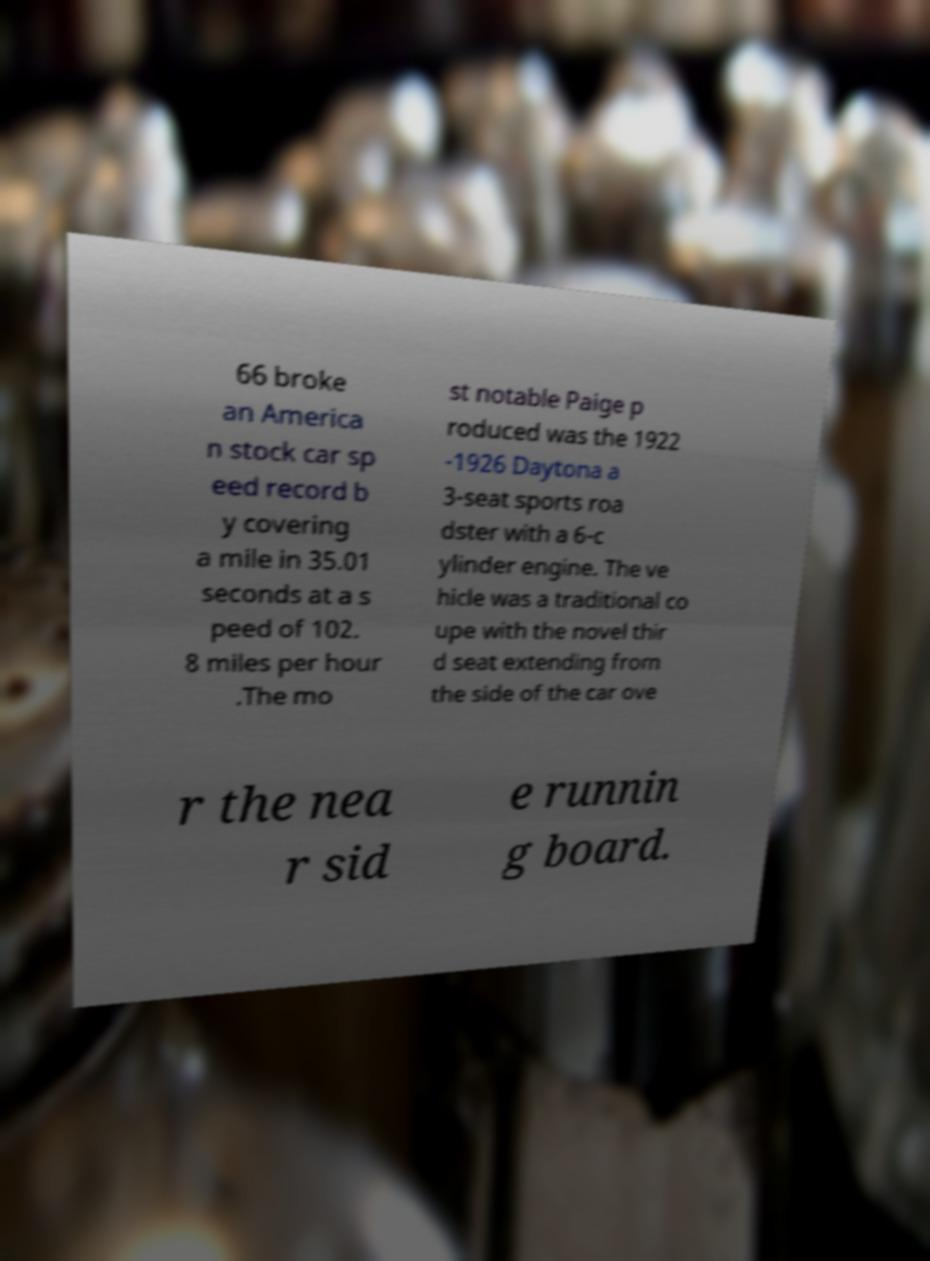Could you assist in decoding the text presented in this image and type it out clearly? 66 broke an America n stock car sp eed record b y covering a mile in 35.01 seconds at a s peed of 102. 8 miles per hour .The mo st notable Paige p roduced was the 1922 -1926 Daytona a 3-seat sports roa dster with a 6-c ylinder engine. The ve hicle was a traditional co upe with the novel thir d seat extending from the side of the car ove r the nea r sid e runnin g board. 